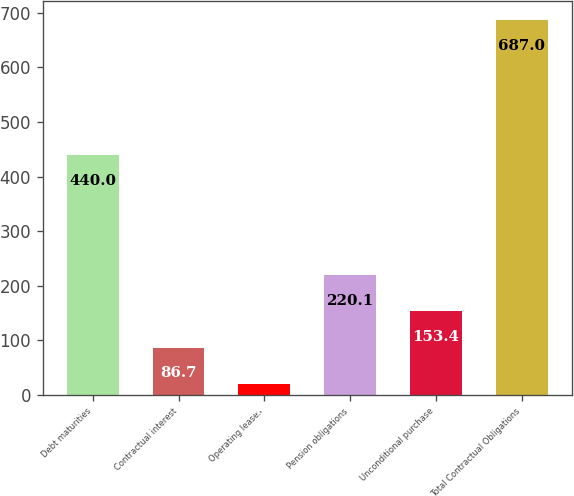<chart> <loc_0><loc_0><loc_500><loc_500><bar_chart><fcel>Debt maturities<fcel>Contractual interest<fcel>Operating leases<fcel>Pension obligations<fcel>Unconditional purchase<fcel>Total Contractual Obligations<nl><fcel>440<fcel>86.7<fcel>20<fcel>220.1<fcel>153.4<fcel>687<nl></chart> 